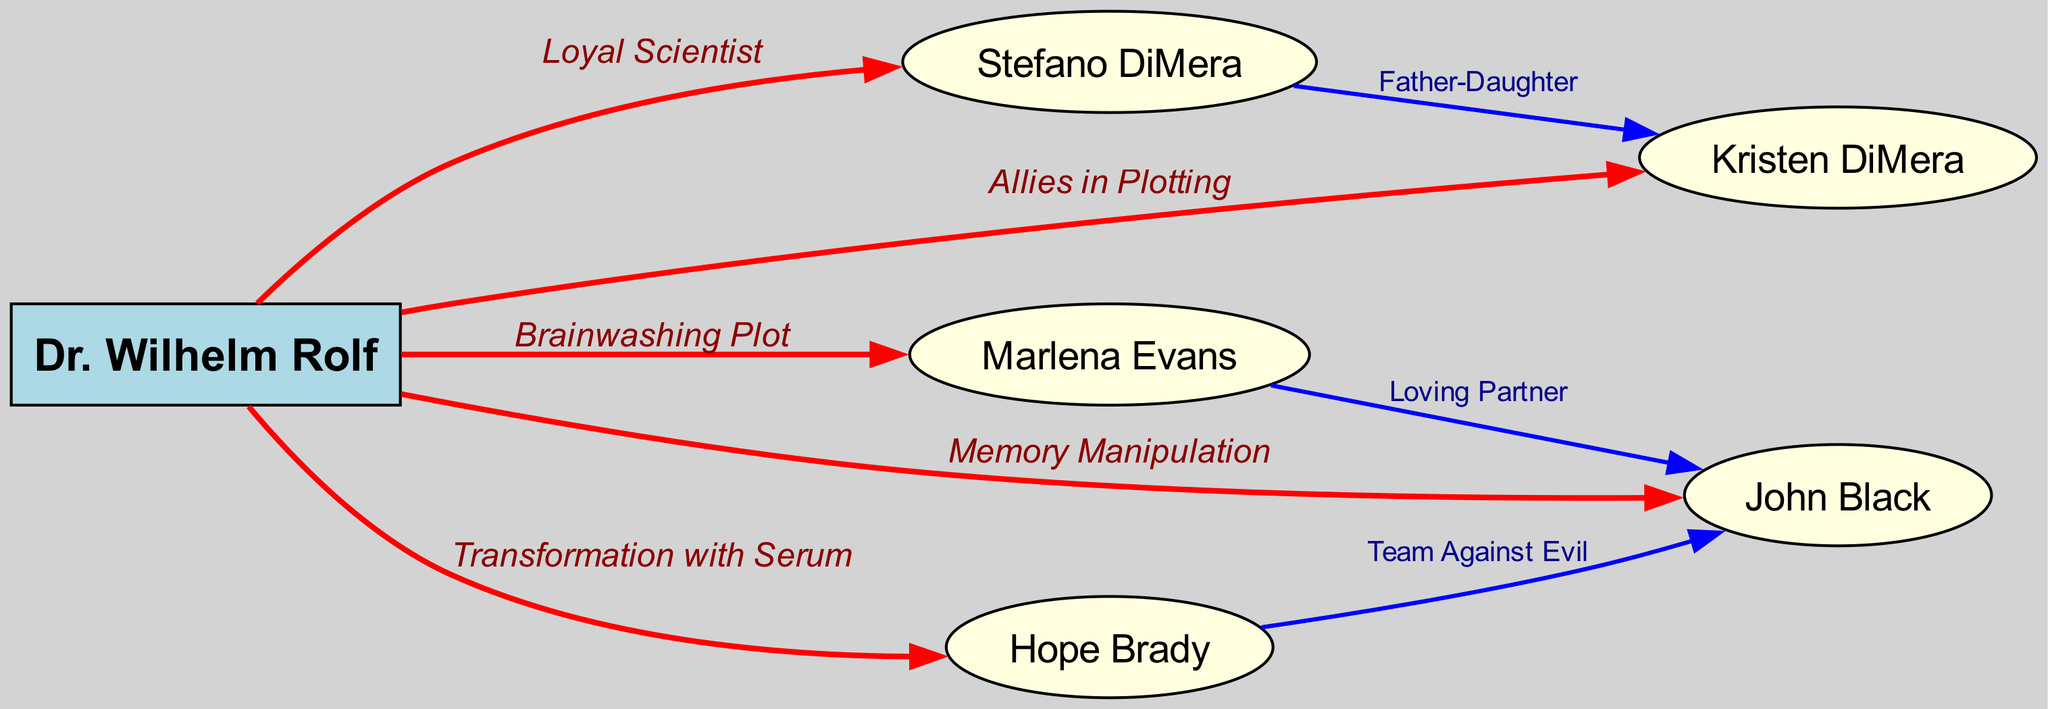What is the label of the edge connecting Dr. Wilhelm Rolf and Stefano DiMera? The edge between Dr. Wilhelm Rolf and Stefano DiMera is labeled "Loyal Scientist," indicating their relationship.
Answer: Loyal Scientist How many characters are directly connected to Dr. Wilhelm Rolf in the diagram? Dr. Wilhelm Rolf has five direct connections shown in the diagram: Stefano DiMera, Kristen DiMera, Marlena Evans, John Black, and Hope Brady.
Answer: 5 What type of relationship is shown between Dr. Wilhelm Rolf and Kristen DiMera? The relationship between Dr. Wilhelm Rolf and Kristen DiMera is labeled "Allies in Plotting," suggesting their collaborative efforts.
Answer: Allies in Plotting Who is the father of Kristen DiMera? The diagram depicts a relationship labeled "Father-Daughter" between Stefano DiMera and Kristen DiMera. Thus, Stefano DiMera is the father.
Answer: Stefano DiMera In the diagram, what plot did Dr. Wilhelm Rolf use against Marlena Evans? The edge connecting Dr. Wilhelm Rolf and Marlena Evans is labeled "Brainwashing Plot," detailing the antagonistic action Dr. Rolf took.
Answer: Brainwashing Plot Which character is described as a "Loving Partner" in the diagram? The edge connecting Marlena Evans to John Black is labeled "Loving Partner," indicating their romantic relationship.
Answer: John Black What is the nature of the relationship between Hope Brady and John Black? The relationship is described with the label "Team Against Evil," showing their collaborative stance against adversities.
Answer: Team Against Evil What color represents Dr. Wilhelm Rolf in the diagram? Dr. Wilhelm Rolf is represented with a light blue color, distinguishing him from the other characters in the diagram.
Answer: Light Blue How many edges are connected to Dr. Wilhelm Rolf? Dr. Wilhelm Rolf has five edges connecting him to different characters, each representing various relationships and actions.
Answer: 5 